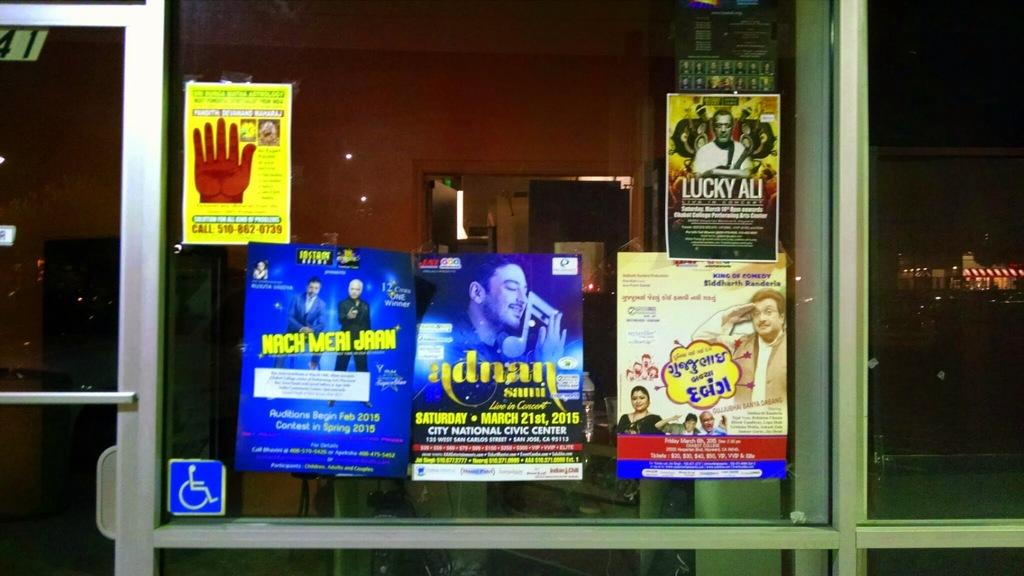<image>
Summarize the visual content of the image. A poster for Lucky Ali hanging in the window of a store. 